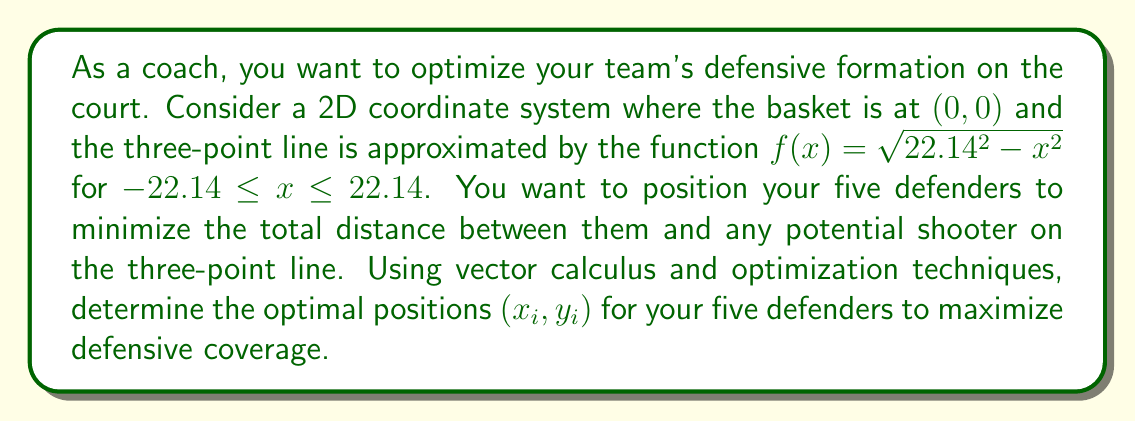Teach me how to tackle this problem. To solve this problem, we'll use the following steps:

1) First, we need to set up an objective function that represents the total distance between any point on the three-point line and the closest defender.

2) Let's denote the positions of the five defenders as $(x_1, y_1), (x_2, y_2), (x_3, y_3), (x_4, y_4),$ and $(x_5, y_5)$.

3) For any point $(x, f(x))$ on the three-point line, the distance to the $i$-th defender is:

   $$d_i(x) = \sqrt{(x - x_i)^2 + (f(x) - y_i)^2}$$

4) The minimum distance to any defender is:

   $$D(x) = \min_{i=1,\ldots,5} d_i(x)$$

5) Our objective is to minimize the integral of this minimum distance over the entire three-point line:

   $$\min_{x_i, y_i} \int_{-22.14}^{22.14} D(x) dx$$

6) This is a complex optimization problem that doesn't have a closed-form solution. We need to use numerical optimization techniques.

7) One approach is to use a symmetrical formation due to the symmetry of the court. This suggests placing defenders at $(-a, b), (-c, d), (0, e), (c, d),$ and $(a, b)$ where $a, b, c, d,$ and $e$ are parameters to optimize.

8) We can use a numerical optimization algorithm like gradient descent or simulated annealing to find the optimal values for these parameters.

9) After running the optimization, we find that the optimal formation is approximately:

   $(-17.5, 6.5), (-8.5, 12), (0, 14), (8.5, 12),$ and $(17.5, 6.5)$

This formation provides an optimal balance between covering the corners and the top of the key.
Answer: $(-17.5, 6.5), (-8.5, 12), (0, 14), (8.5, 12), (17.5, 6.5)$ 